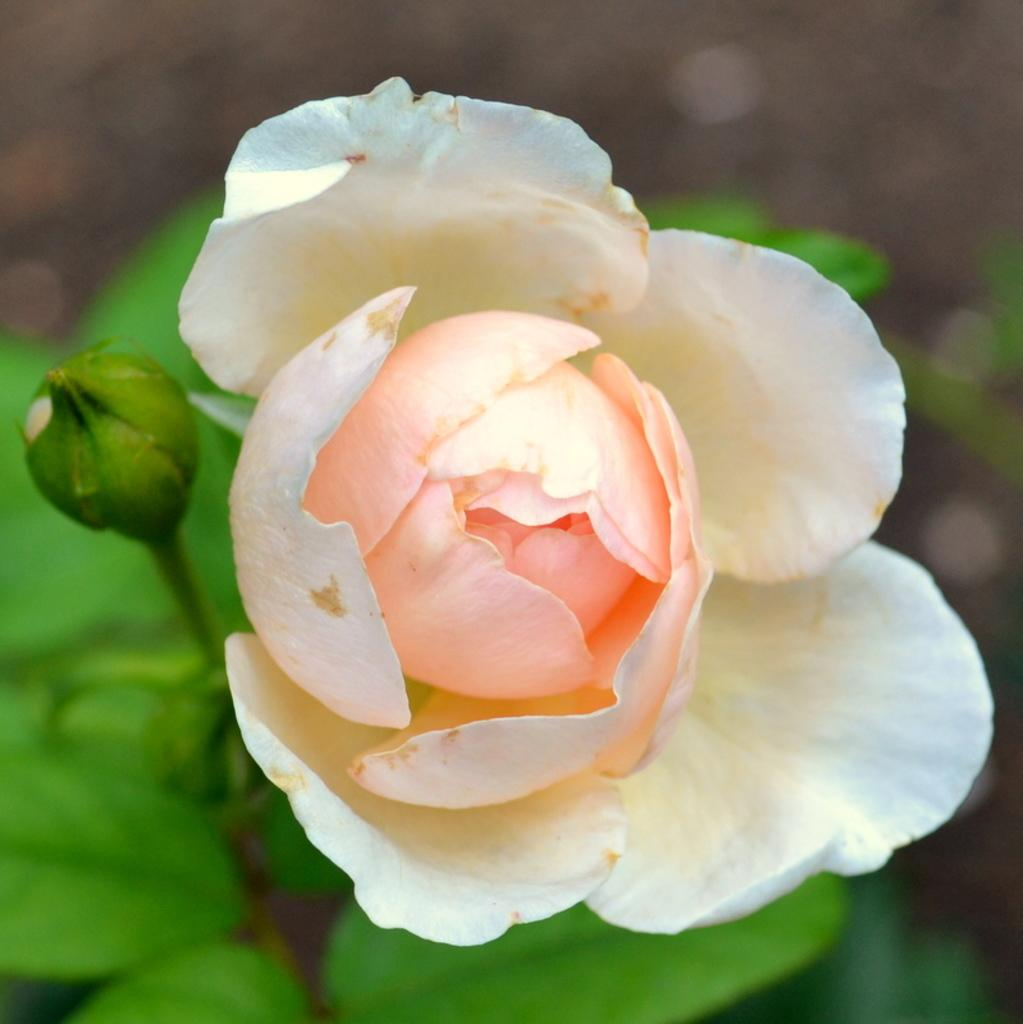What is the main subject of the image? There is a flower in the image. Can you describe the flower in more detail? The flower belongs to a plant. How many kitties are playing with the flower in the image? There are no kitties present in the image; it only features a flower belonging to a plant. What type of land can be seen in the image? The image does not show any land; it only features a flower belonging to a plant. 